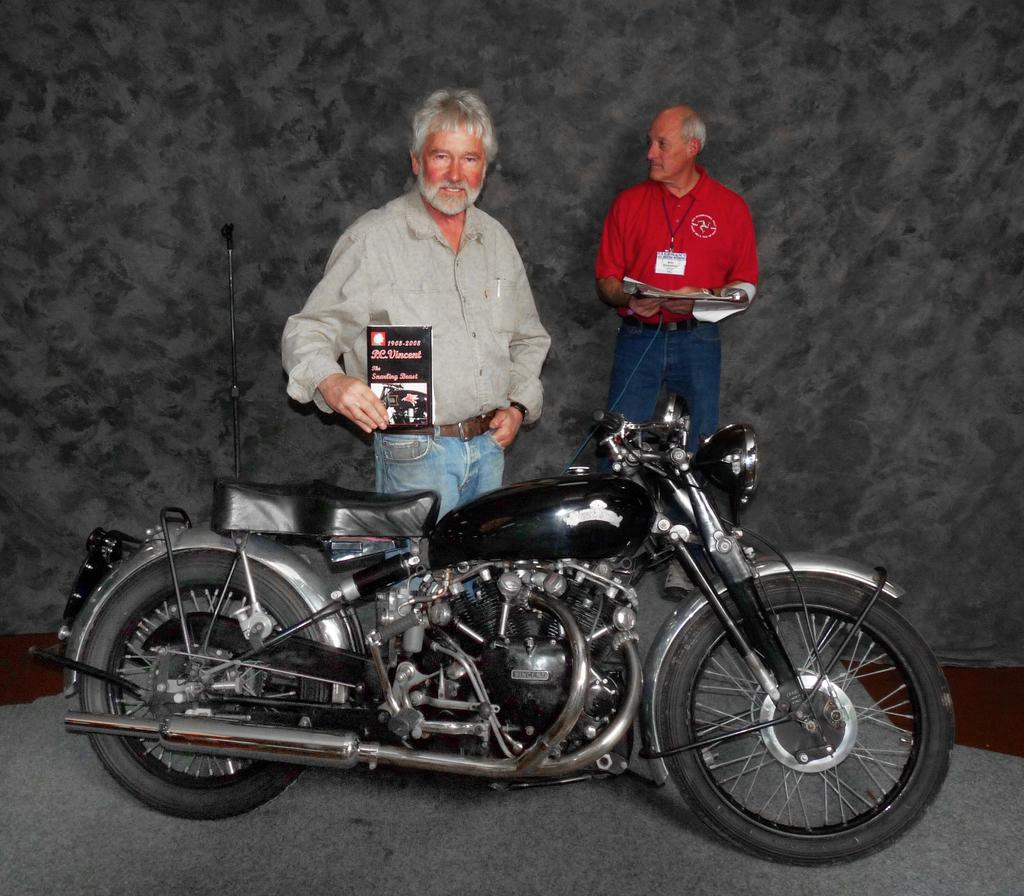What is the main object in the center of the image? There is a bike in the center of the image. Who is positioned behind the bike? A man is behind the bike. What is the man behind the bike holding? The man behind the bike is holding a pamphlet in his hand. Can you describe the other person in the image? There is in the background area. A: There is another man in the background area, and he is holding papers in his hands. Where is the tray located in the image? There is no tray present in the image. What type of territory is being claimed by the man in the background? There is no indication of territory being claimed in the image; the man in the background is simply holding papers in his hands. 